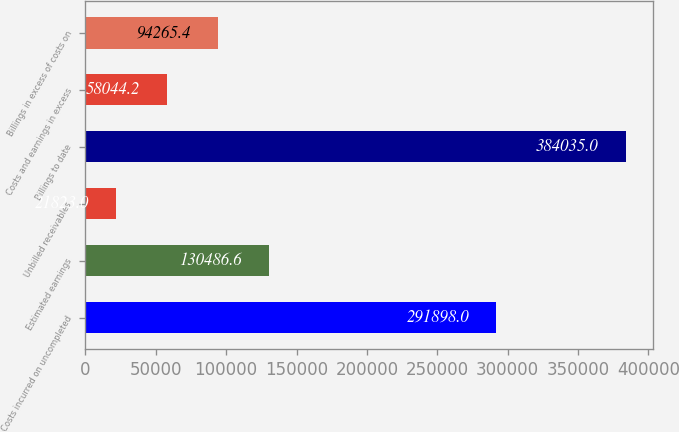Convert chart. <chart><loc_0><loc_0><loc_500><loc_500><bar_chart><fcel>Costs incurred on uncompleted<fcel>Estimated earnings<fcel>Unbilled receivables<fcel>Billings to date<fcel>Costs and earnings in excess<fcel>Billings in excess of costs on<nl><fcel>291898<fcel>130487<fcel>21823<fcel>384035<fcel>58044.2<fcel>94265.4<nl></chart> 